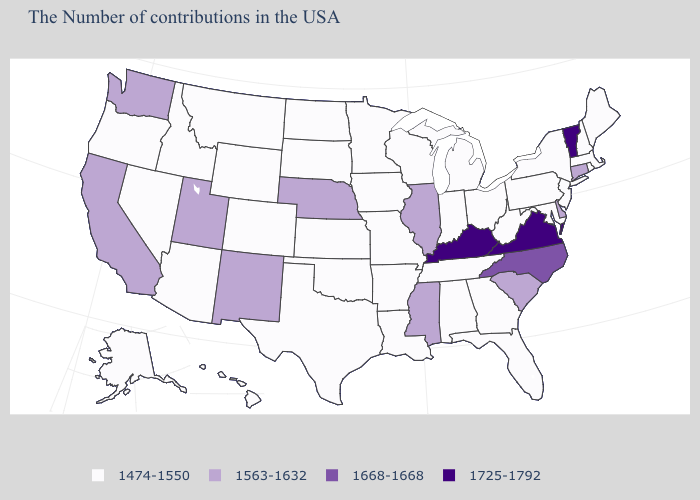What is the value of Iowa?
Give a very brief answer. 1474-1550. Which states hav the highest value in the South?
Quick response, please. Virginia, Kentucky. What is the highest value in the MidWest ?
Be succinct. 1563-1632. How many symbols are there in the legend?
Concise answer only. 4. Name the states that have a value in the range 1474-1550?
Keep it brief. Maine, Massachusetts, Rhode Island, New Hampshire, New York, New Jersey, Maryland, Pennsylvania, West Virginia, Ohio, Florida, Georgia, Michigan, Indiana, Alabama, Tennessee, Wisconsin, Louisiana, Missouri, Arkansas, Minnesota, Iowa, Kansas, Oklahoma, Texas, South Dakota, North Dakota, Wyoming, Colorado, Montana, Arizona, Idaho, Nevada, Oregon, Alaska, Hawaii. Name the states that have a value in the range 1563-1632?
Short answer required. Connecticut, Delaware, South Carolina, Illinois, Mississippi, Nebraska, New Mexico, Utah, California, Washington. What is the lowest value in the USA?
Short answer required. 1474-1550. What is the value of Wyoming?
Quick response, please. 1474-1550. Name the states that have a value in the range 1563-1632?
Write a very short answer. Connecticut, Delaware, South Carolina, Illinois, Mississippi, Nebraska, New Mexico, Utah, California, Washington. What is the value of Alabama?
Short answer required. 1474-1550. Which states have the lowest value in the USA?
Answer briefly. Maine, Massachusetts, Rhode Island, New Hampshire, New York, New Jersey, Maryland, Pennsylvania, West Virginia, Ohio, Florida, Georgia, Michigan, Indiana, Alabama, Tennessee, Wisconsin, Louisiana, Missouri, Arkansas, Minnesota, Iowa, Kansas, Oklahoma, Texas, South Dakota, North Dakota, Wyoming, Colorado, Montana, Arizona, Idaho, Nevada, Oregon, Alaska, Hawaii. Name the states that have a value in the range 1725-1792?
Answer briefly. Vermont, Virginia, Kentucky. What is the value of Oregon?
Concise answer only. 1474-1550. What is the value of Pennsylvania?
Write a very short answer. 1474-1550. 